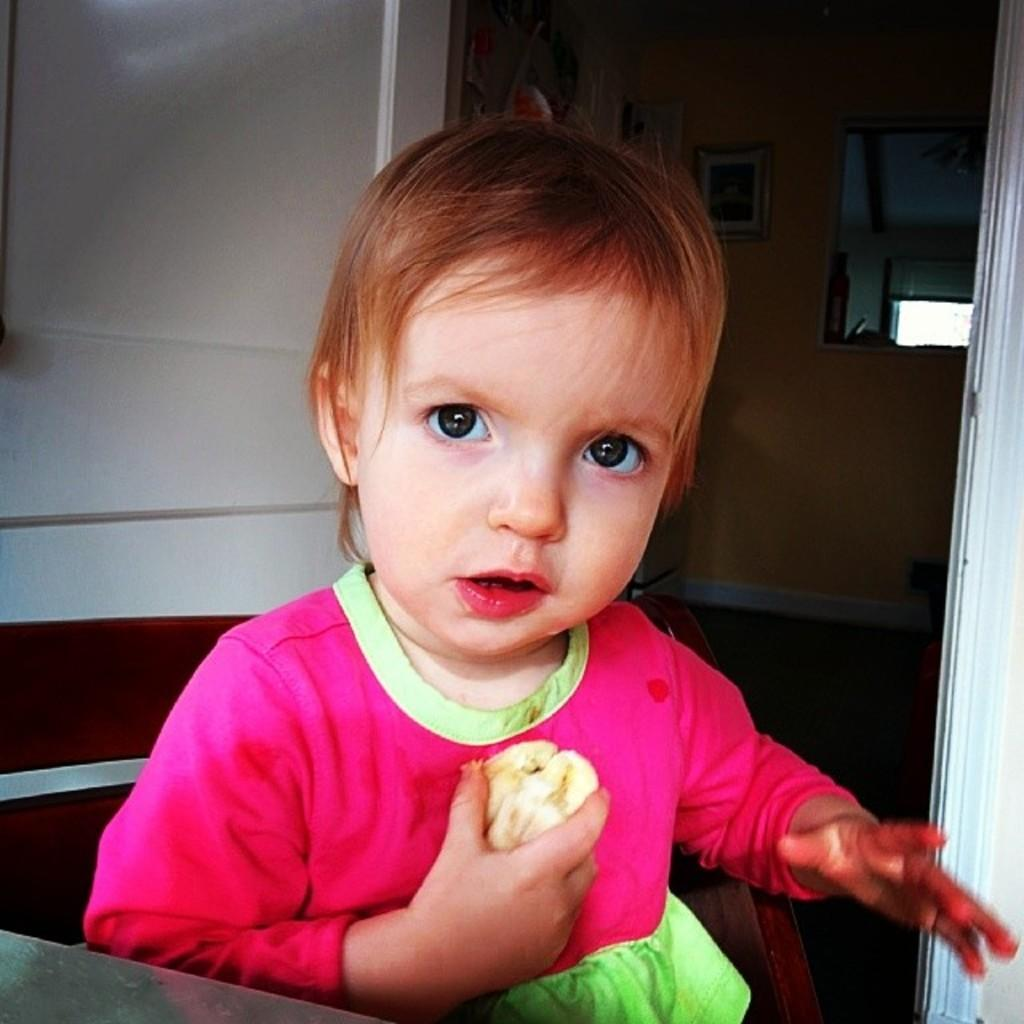Who or what is the main subject of the image? The main subject of the image is a kid. What can be seen in the background of the image? There is a wall in the background of the image. What type of zipper can be seen on the wall in the image? There is no zipper present on the wall in the image. What view can be seen from the kid's perspective in the image? The provided facts do not give enough information to determine the view from the kid's perspective. What authority figure is present in the image? The provided facts do not mention any authority figures in the image. 